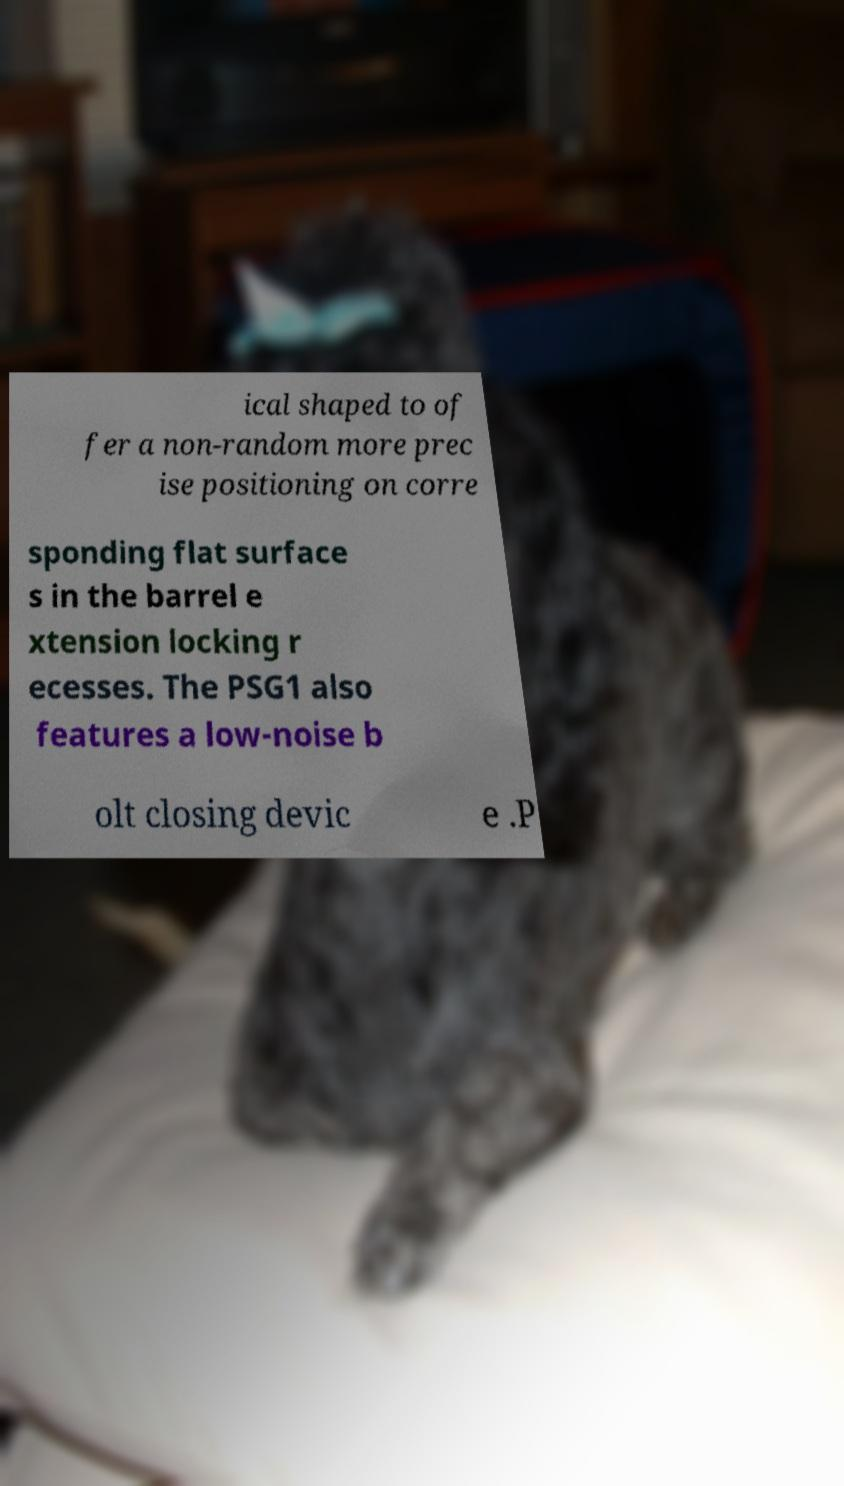Please identify and transcribe the text found in this image. ical shaped to of fer a non-random more prec ise positioning on corre sponding flat surface s in the barrel e xtension locking r ecesses. The PSG1 also features a low-noise b olt closing devic e .P 